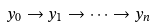<formula> <loc_0><loc_0><loc_500><loc_500>y _ { 0 } \rightarrow y _ { 1 } \rightarrow \cdots \rightarrow y _ { n }</formula> 